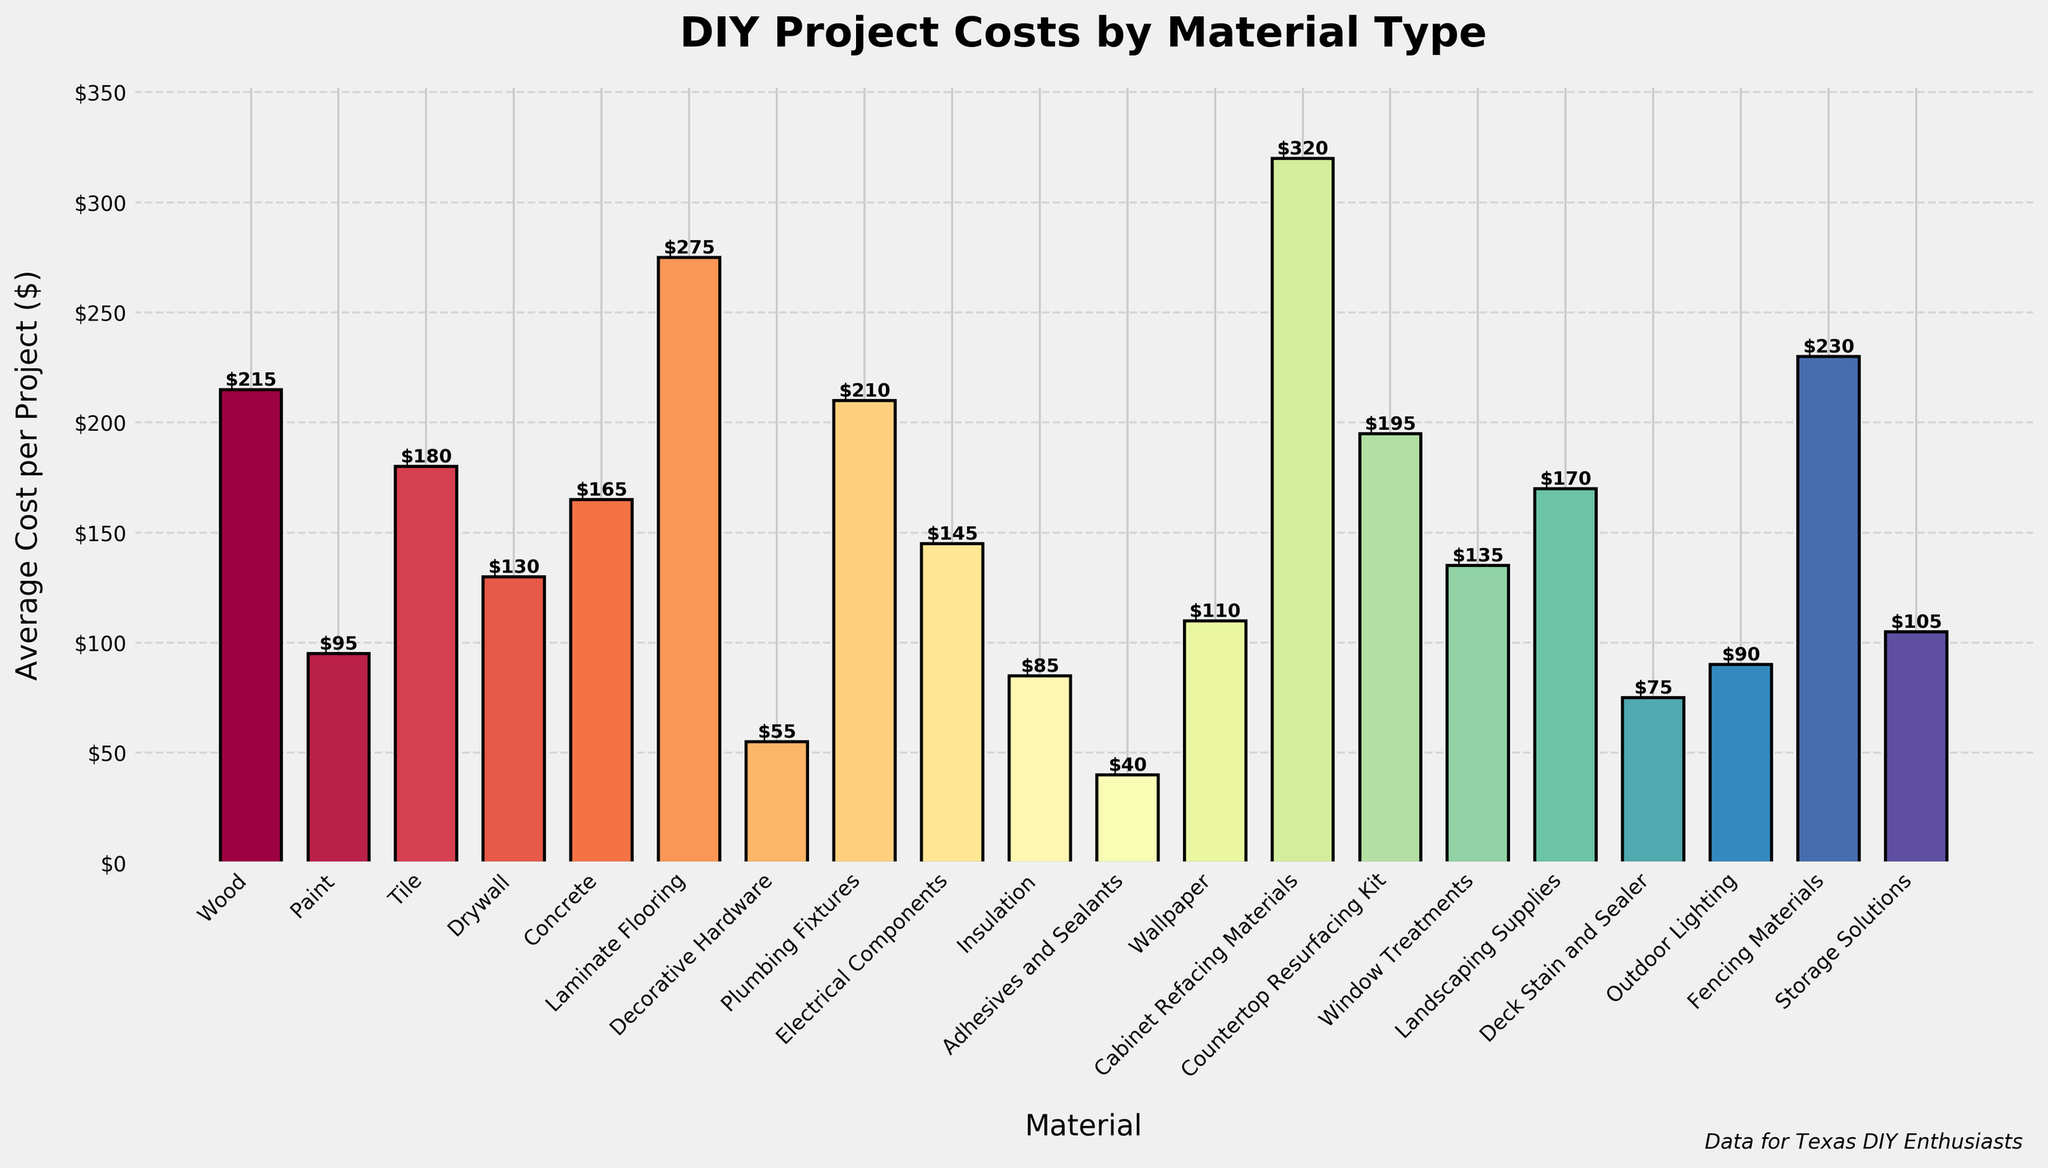What is the most expensive material for DIY projects? The most expensive material is identified by finding the bar with the greatest height and corresponding label. In this case, it is "Cabinet Refacing Materials".
Answer: Cabinet Refacing Materials What is the cheapest material listed? The cheapest material is found by identifying the shortest bar and its label. This bar corresponds to "Adhesives and Sealants" with an average cost of $40 per project.
Answer: Adhesives and Sealants How much more expensive on average are Laminate Flooring projects compared to Paint projects? Subtract the average cost of Paint projects from that of Laminate Flooring projects: $275 - $95 = $180.
Answer: $180 Which material has an average cost closest to $200? Locate the bar with a height closest to $200; "Plumbing Fixtures" at $210 and "Countertop Resurfacing Kit" at $195 are both close, with "Countertop Resurfacing Kit" being the closest.
Answer: Countertop Resurfacing Kit What is the total average cost for Wood, Paint, and Tile combined? Sum the average costs of these materials: $215 (Wood) + $95 (Paint) + $180 (Tile) = $490.
Answer: $490 Are Electrical Components more or less expensive on average than Drywall? Compare the heights of their respective bars: Electrical Components ($145) is more expensive than Drywall ($130).
Answer: More expensive What is the median cost of all the materials listed? Rank all the materials by their average costs and locate the middle value. With 20 items, the median is the average of the 10th and 11th items: ($130 (Drywall) + $135 (Window Treatments))/2 = $132.50.
Answer: $132.50 How many materials have an average cost greater than $150? Count the number of bars with heights above $150. The materials are Wood, Tile, Concrete, Laminate Flooring, Plumbing Fixtures, Electrical Components, Fencing Materials, Cabinet Refacing Materials, Countertop Resurfacing Kit (i.e., 9 materials).
Answer: 9 Which material associated with outdoor projects has the highest average cost? Identify materials connected to outdoor projects (e.g., Landscaping Supplies, Deck Stain and Sealer, Outdoor Lighting, Fencing Materials) and compare their costs. Fencing Materials has the highest cost at $230.
Answer: Fencing Materials If you were to decide between Wallpaper or Window Treatments based solely on cost, which would be cheaper? Compare the average costs of Wallpaper ($110) and Window Treatments ($135). Wallpaper is cheaper.
Answer: Wallpaper 